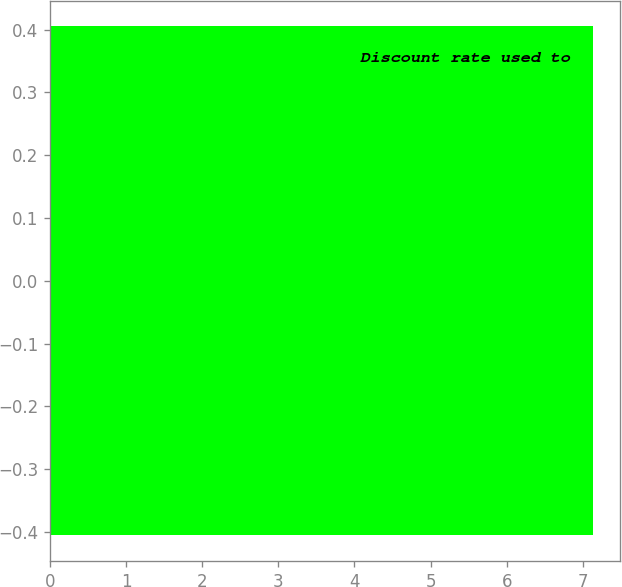<chart> <loc_0><loc_0><loc_500><loc_500><bar_chart><fcel>Discount rate used to<nl><fcel>7.13<nl></chart> 